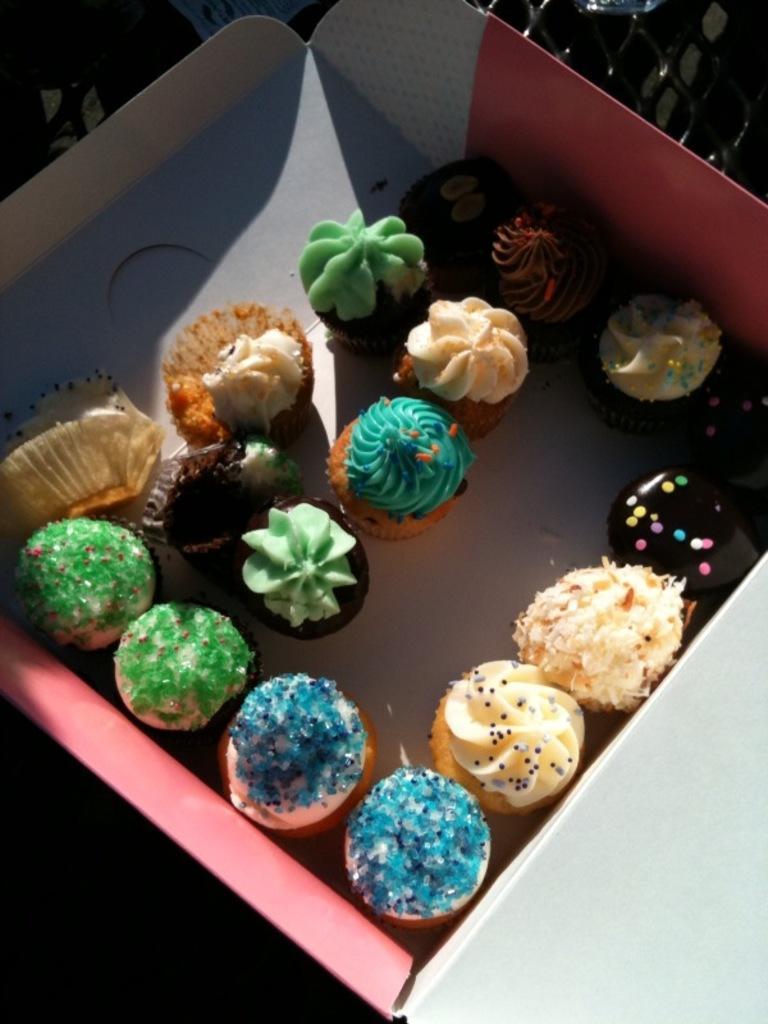In one or two sentences, can you explain what this image depicts? This image consists of a box. In that there are so many cupcakes. 